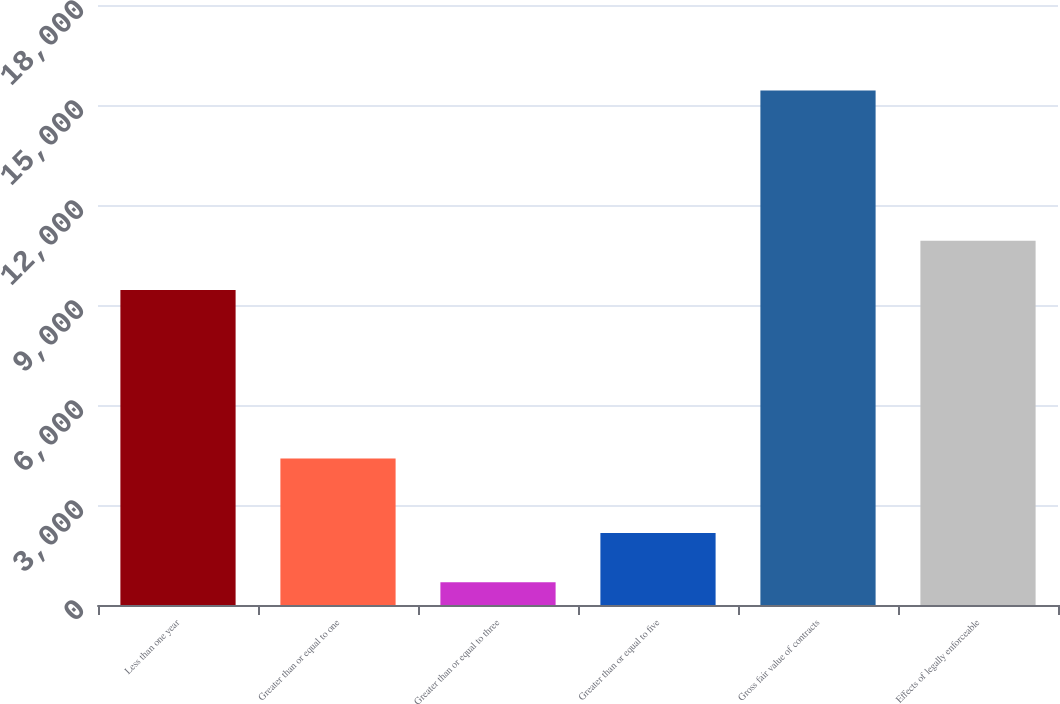Convert chart. <chart><loc_0><loc_0><loc_500><loc_500><bar_chart><fcel>Less than one year<fcel>Greater than or equal to one<fcel>Greater than or equal to three<fcel>Greater than or equal to five<fcel>Gross fair value of contracts<fcel>Effects of legally enforceable<nl><fcel>9453<fcel>4395<fcel>682<fcel>2157.1<fcel>15433<fcel>10928.1<nl></chart> 